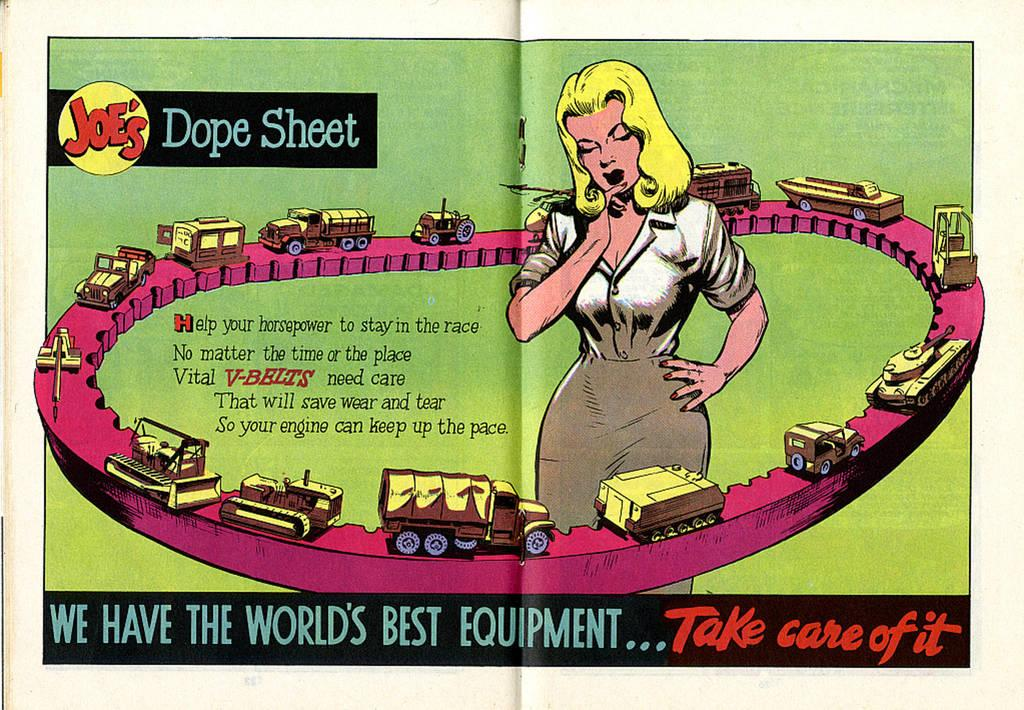<image>
Create a compact narrative representing the image presented. magazine that says take care of it at the bottom 